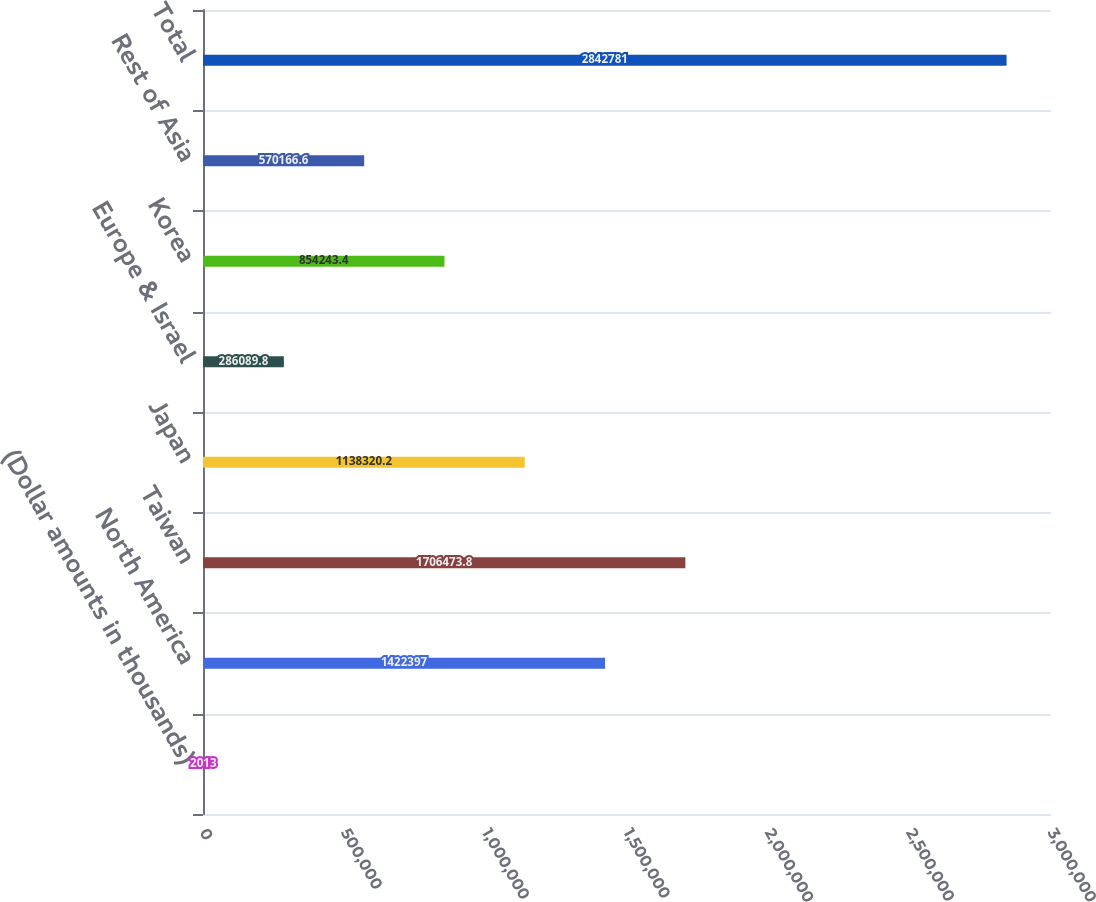<chart> <loc_0><loc_0><loc_500><loc_500><bar_chart><fcel>(Dollar amounts in thousands)<fcel>North America<fcel>Taiwan<fcel>Japan<fcel>Europe & Israel<fcel>Korea<fcel>Rest of Asia<fcel>Total<nl><fcel>2013<fcel>1.4224e+06<fcel>1.70647e+06<fcel>1.13832e+06<fcel>286090<fcel>854243<fcel>570167<fcel>2.84278e+06<nl></chart> 